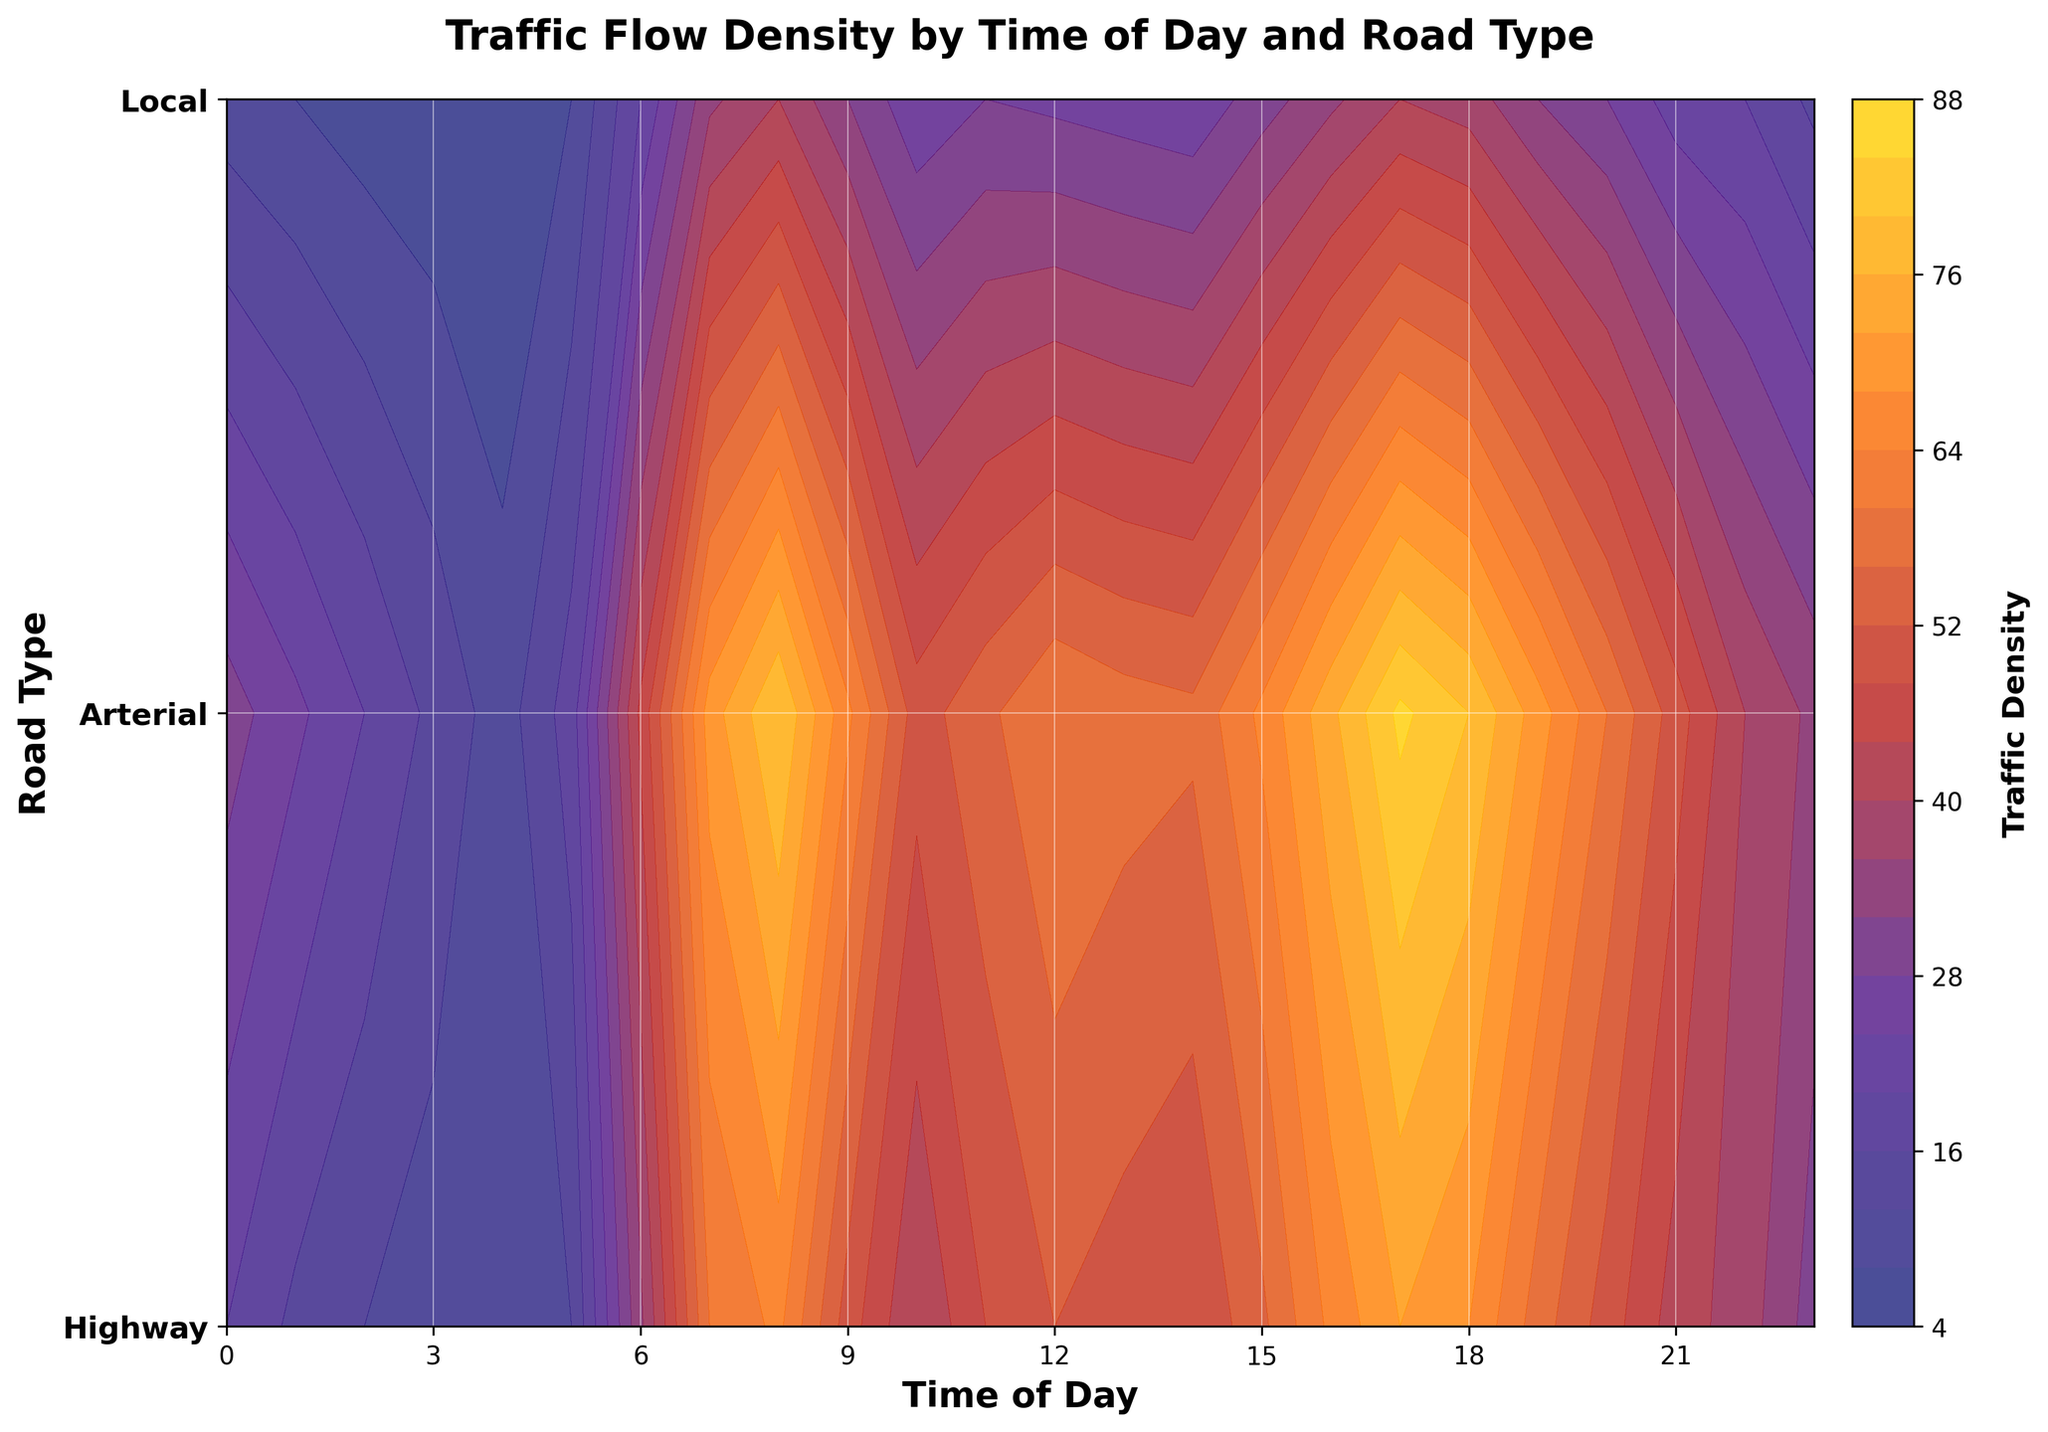What is the title of the figure? The title is typically located at the top of the plot, clearly marked and displayed in bold. Here, it reads 'Traffic Flow Density by Time of Day and Road Type'.
Answer: Traffic Flow Density by Time of Day and Road Type Which road type shows the highest traffic density around 8 AM? Inspect the 8 AM (08:00) column for the highest traffic density value. Look at the row labels to identify the corresponding road type. The highest value at 8 AM is 80 for the Highway.
Answer: Highway At what times of day are the morning and evening peaks indicated in the figure? Look at the annotations in the figure marked 'Morning Peak' and 'Evening Peak'. The arrows point to 7 AM for the morning peak and 5 PM (17:00) for the evening peak.
Answer: 7 AM and 5 PM During the evening peak, which road type has the lowest traffic density? Observe the 5 PM (17:00) column and compare the values for each road type. The lowest value is 40, which corresponds to the Local road.
Answer: Local How does the traffic density at noon compare between the Highway and Local roads? Identify the traffic density values for the Highway and Local roads at 12 PM (Noon). The values are 60 for Highway and 27 for Local. The Highway has a higher traffic density than the Local road.
Answer: Highway is higher What is the traffic density range for Arterial roads throughout the day? Find the minimum and maximum traffic densities for Arterial roads from 0 to 23 hours. The values range from 8 at 4 AM to 72 at 5 PM.
Answer: 8 to 72 Describe the general trend of traffic density for Local roads throughout the day. Starting from a low value of 10 at midnight, Local road traffic density increases steadily, peaks around 8 AM and 5 PM, and then decreases again.
Answer: Increases, peaks at 8 AM and 5 PM, then decreases Which time period shows the sharpest increase in traffic density for Highway roads? Compare the changes in traffic density between consecutive hours for Highway roads. The sharpest increase occurs from 5 AM (18) to 6 AM (45).
Answer: Between 5 AM and 6 AM What is the overall traffic density trend on Highways from 6 PM to 9 PM? Look at the hours from 6 PM to 9 PM for Highways. Traffic density decreases from 80 to 60.
Answer: Decreasing Which road type appears to be the most affected by traffic density during the evening peak hours? Compare the density values across all road types during the evening peak at 5 PM (17:00). Highway, with a value of 85, shows the highest impact.
Answer: Highway 